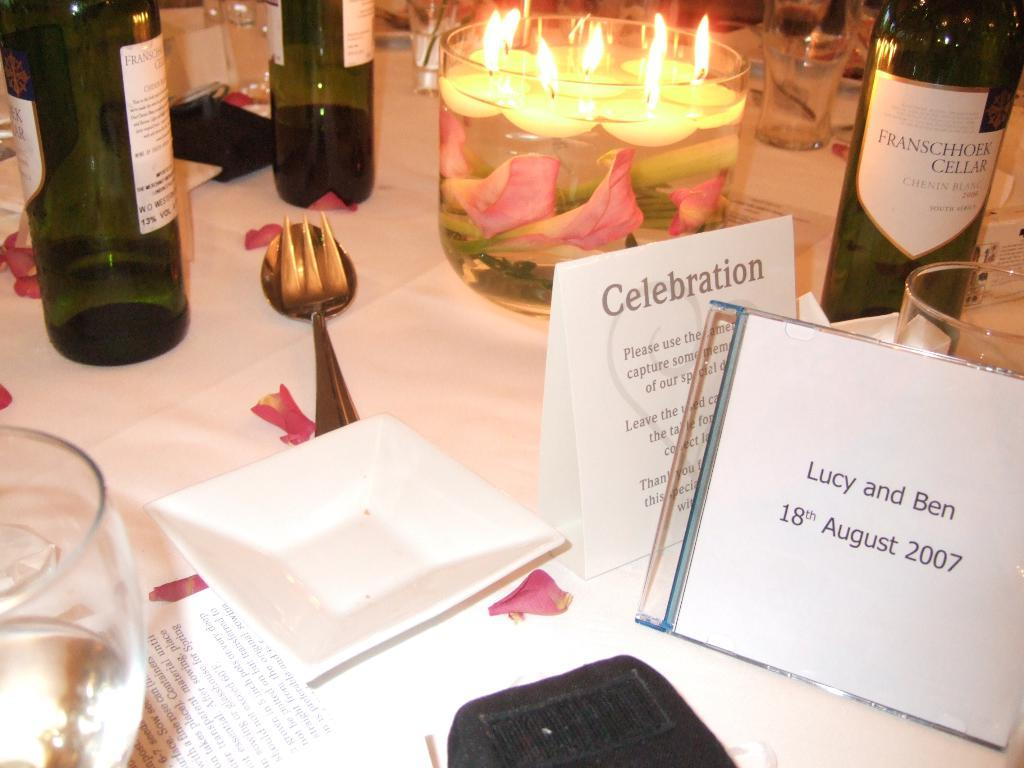What utensils can be seen in the image? There is a fork and a spoon in the image. What is the dishware item present in the image? There is a plate in the image. What stationery item is visible in the image? There is a card in the image. What type of containers are present in the image? There are bottles in the image. What light source is present in the image? There is a candle in the image. What is the glass containing in the image? There is a glass with water in the image. What type of writing material is present in the image? There are papers on a table in the image. What type of knee can be seen in the image? There is no knee present in the image. What type of sail is visible in the image? There is no sail present in the image. 